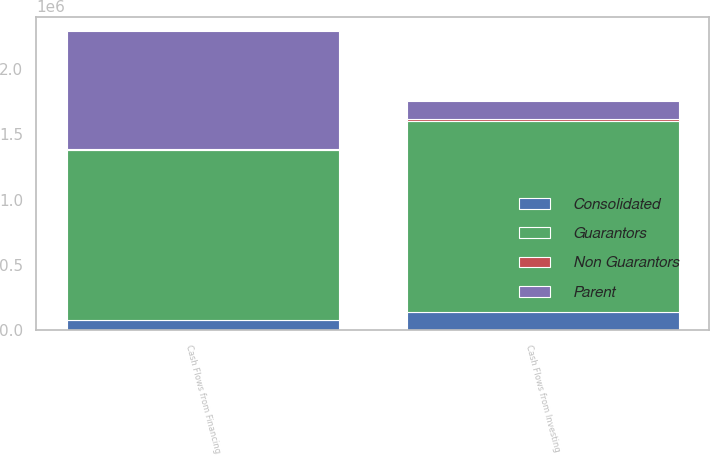Convert chart. <chart><loc_0><loc_0><loc_500><loc_500><stacked_bar_chart><ecel><fcel>Cash Flows from Investing<fcel>Cash Flows from Financing<nl><fcel>Guarantors<fcel>1.45719e+06<fcel>1.30519e+06<nl><fcel>Parent<fcel>139902<fcel>901603<nl><fcel>Non Guarantors<fcel>14609<fcel>4515<nl><fcel>Consolidated<fcel>142760<fcel>77258<nl></chart> 